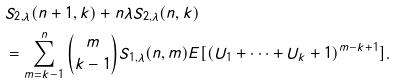Convert formula to latex. <formula><loc_0><loc_0><loc_500><loc_500>& S _ { 2 , \lambda } ( n + 1 , k ) + n \lambda S _ { 2 , \lambda } ( n , k ) \\ & = \sum _ { m = k - 1 } ^ { n } { m \choose k - 1 } S _ { 1 , \lambda } ( n , m ) E [ ( U _ { 1 } + \cdots + U _ { k } + 1 ) ^ { m - k + 1 } ] .</formula> 